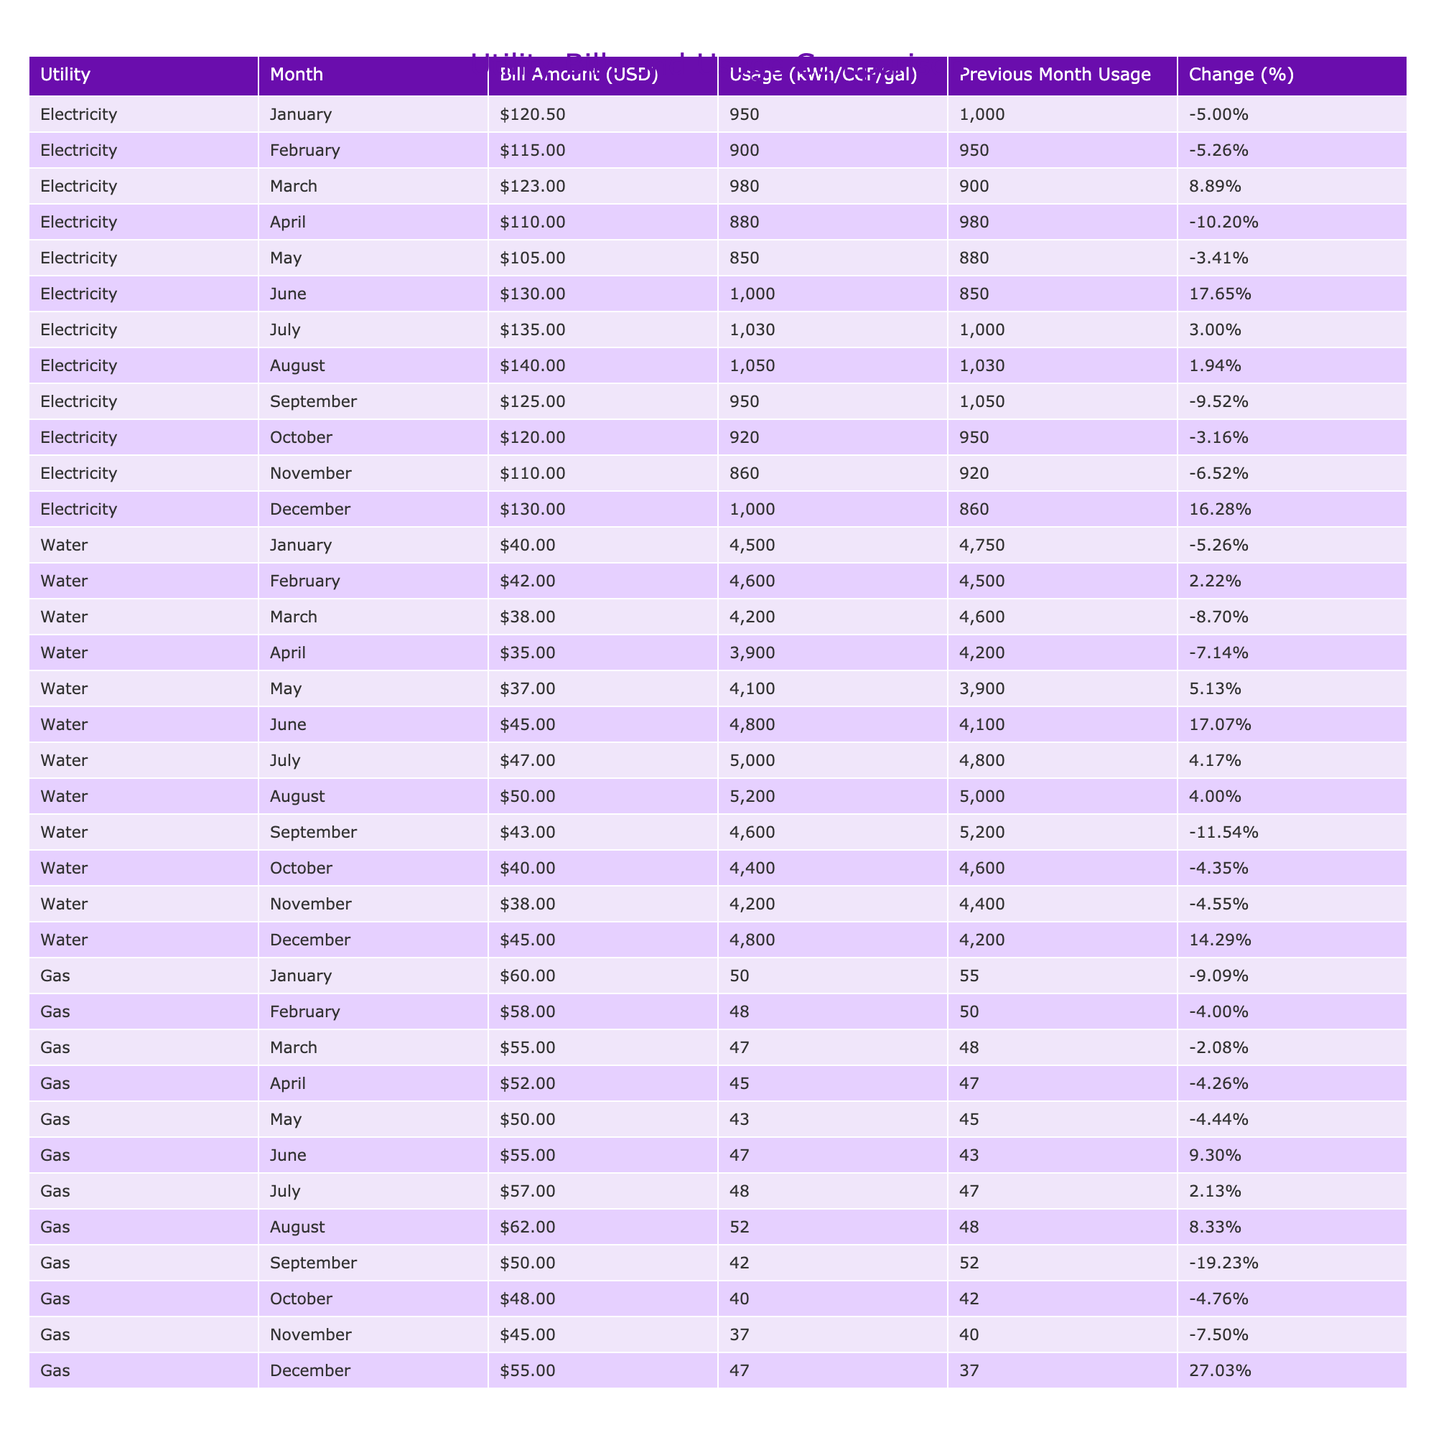What was the highest electricity bill amount recorded? Looking through the 'Bill Amount (USD)' column under 'Electricity', the highest value is 140.00 in the month of August.
Answer: 140.00 Which month had the highest water usage? In the 'Usage (kWh/CCF/gal)' column for 'Water', the highest value is 5200, which occurred in August.
Answer: 5200 Did the gas bill increase in December compared to the previous month? In December, the gas bill is listed as 55.00, and the previous month (November) it was 45.00. Since 55.00 is greater than 45.00, the bill increased.
Answer: Yes What is the average water bill amount for the entire year? Summing the water bills from January (40.00) to December (45.00) gives: 40 + 42 + 38 + 35 + 37 + 45 + 47 + 50 + 43 + 40 + 38 + 45 =  515.00. Dividing by 12 months results in an average of 4316.67.
Answer: 4316.67 Was there a month where the electricity usage was exactly 1000 kWh? Looking in the 'Usage (kWh/CCF/gal)' column for 'Electricity', the exact usage of 1000 kWh was recorded in January and June, confirming there were two such instances.
Answer: Yes What was the percentage change in gas usage from November to December? In November, the usage was 37, and in December it increased to 47. The percentage change is calculated as ((47 - 37)/37) * 100 = 27.03%.
Answer: 27.03% In which month did water usage see the largest decrease compared to the previous month? When checking the 'Change (%)' column for 'Water', the largest decrease is -11.54%, occurring in September compared to August.
Answer: September Which utility had the lowest bill in April? Comparing the bills in the 'Bill Amount (USD)' column for all utilities in April, the lowest amount is 35.00 for water.
Answer: 35.00 